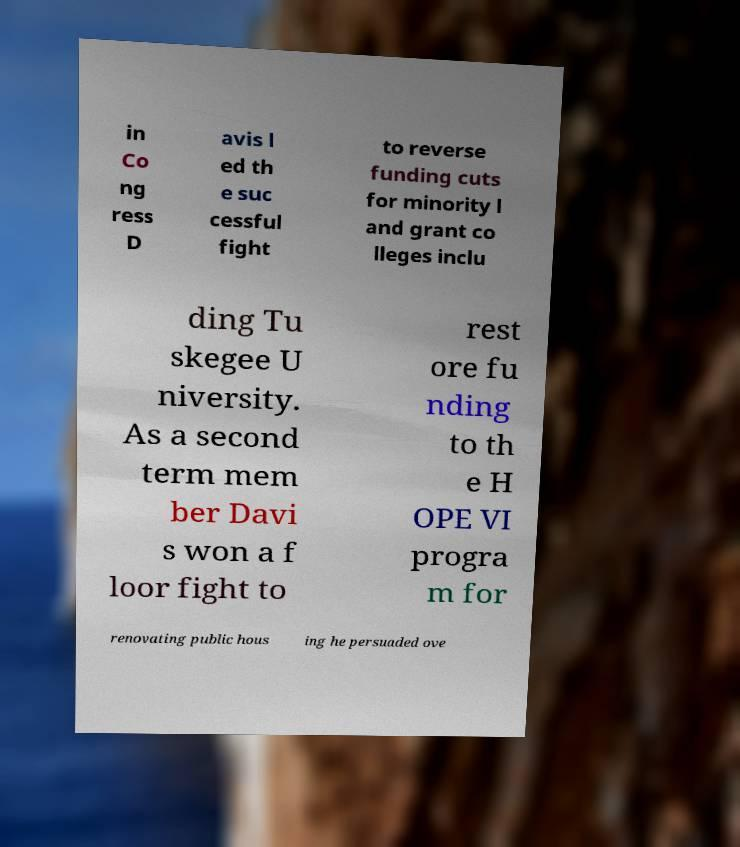What messages or text are displayed in this image? I need them in a readable, typed format. in Co ng ress D avis l ed th e suc cessful fight to reverse funding cuts for minority l and grant co lleges inclu ding Tu skegee U niversity. As a second term mem ber Davi s won a f loor fight to rest ore fu nding to th e H OPE VI progra m for renovating public hous ing he persuaded ove 